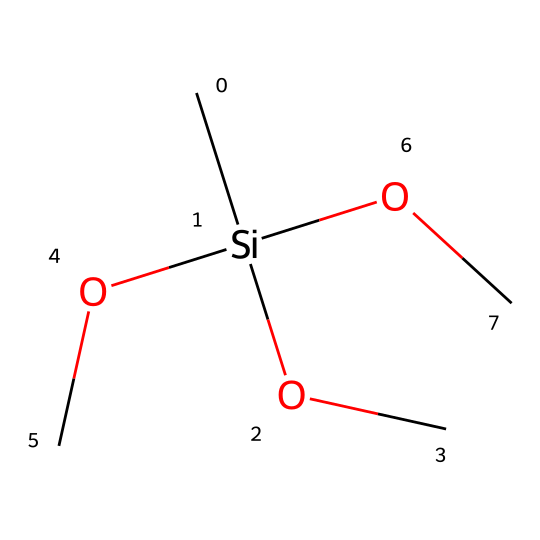What is the main functional group present in this molecule? The molecule contains -OC (alkoxy) groups, which indicates the presence of ether functionalities. The central silicon atom is connected to three of these ether groups, identifying the overall functional group as trialkoxysilane.
Answer: trialkoxysilane How many oxygen atoms are in the molecule? By analyzing the SMILES notation, each -OC represents an oxygen atom. Since there are three -OC groups attached to the silicon, there are a total of three oxygen atoms.
Answer: 3 What type of silane is represented by this SMILES structure? The structure includes three alkoxy groups attached to the silicon atom, classifying it as a trialkoxysilane derivative, which is specifically used for surface modifications like biocompatibility.
Answer: trialkoxysilane derivative Does this molecule have any hydrogen atoms attached to the silicon atom? In the given SMILES, there are no explicit hydrogen atoms directly bonded to the silicon because all of the valences of silicon are satisfied by the three alkoxy groups, indicating a complete substitution.
Answer: no How many carbon atoms are present in this compound? Each -OC group contains one carbon atom, and with three such groups present in the structure, we have a total of three carbon atoms contributing to the molecule.
Answer: 3 What potential application does this molecule have in medical devices? Given that this molecule is a trialkoxysilane, it can be used in surface coatings for medical implants to enhance biocompatibility and reduce rejection rates by the body.
Answer: biocompatible coatings 